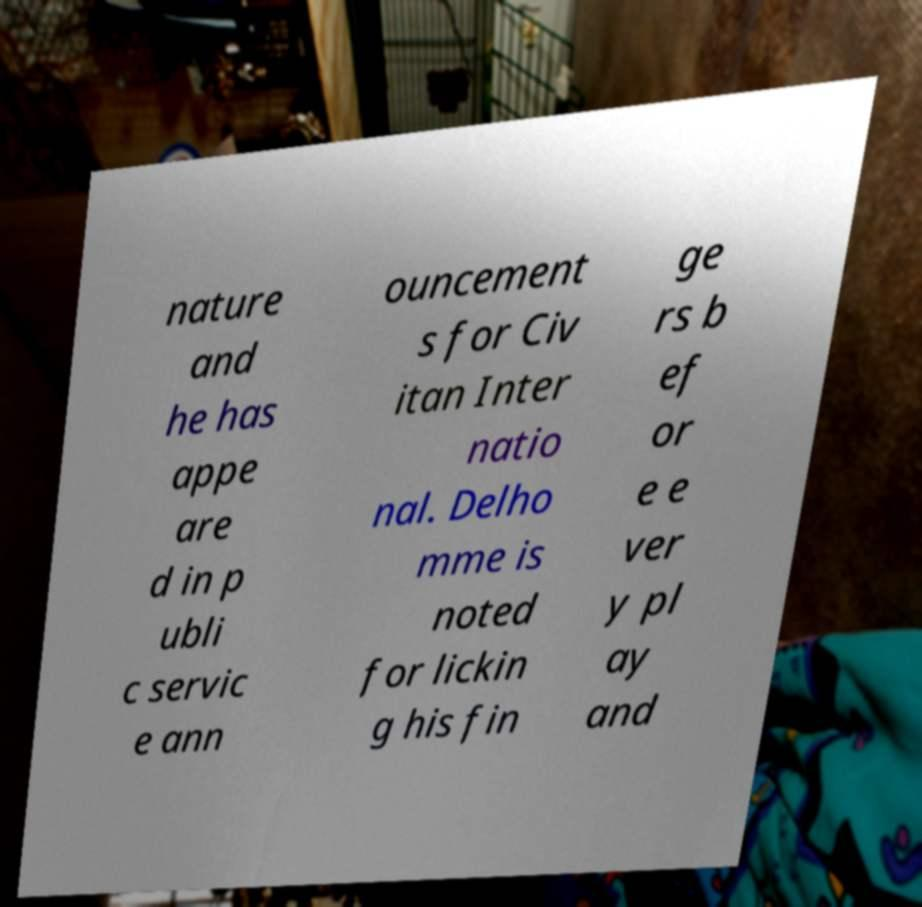Please identify and transcribe the text found in this image. nature and he has appe are d in p ubli c servic e ann ouncement s for Civ itan Inter natio nal. Delho mme is noted for lickin g his fin ge rs b ef or e e ver y pl ay and 